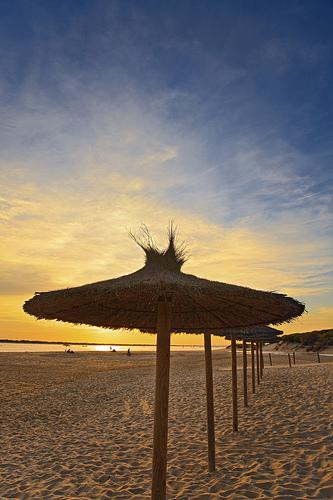Question: what are the colors of the sky?
Choices:
A. Black, white, and silver.
B. Red, orange, and yellow.
C. Blue, white and gold.
D. Blue, gray, and pink.
Answer with the letter. Answer: C Question: who are the people in the distance?
Choices:
A. Singers.
B. Beachgoers.
C. Business people.
D. Politicians.
Answer with the letter. Answer: B Question: what are the shades made of?
Choices:
A. Wood and brick.
B. Stone and paper.
C. Wood and dry leaves.
D. Leaves and cloth.
Answer with the letter. Answer: C Question: when is the sun going to set?
Choices:
A. In five hours.
B. In twelve hours.
C. In six days.
D. The sun is already starting to set.
Answer with the letter. Answer: D 